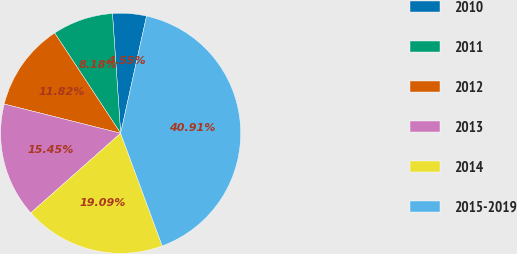Convert chart to OTSL. <chart><loc_0><loc_0><loc_500><loc_500><pie_chart><fcel>2010<fcel>2011<fcel>2012<fcel>2013<fcel>2014<fcel>2015-2019<nl><fcel>4.55%<fcel>8.18%<fcel>11.82%<fcel>15.45%<fcel>19.09%<fcel>40.91%<nl></chart> 